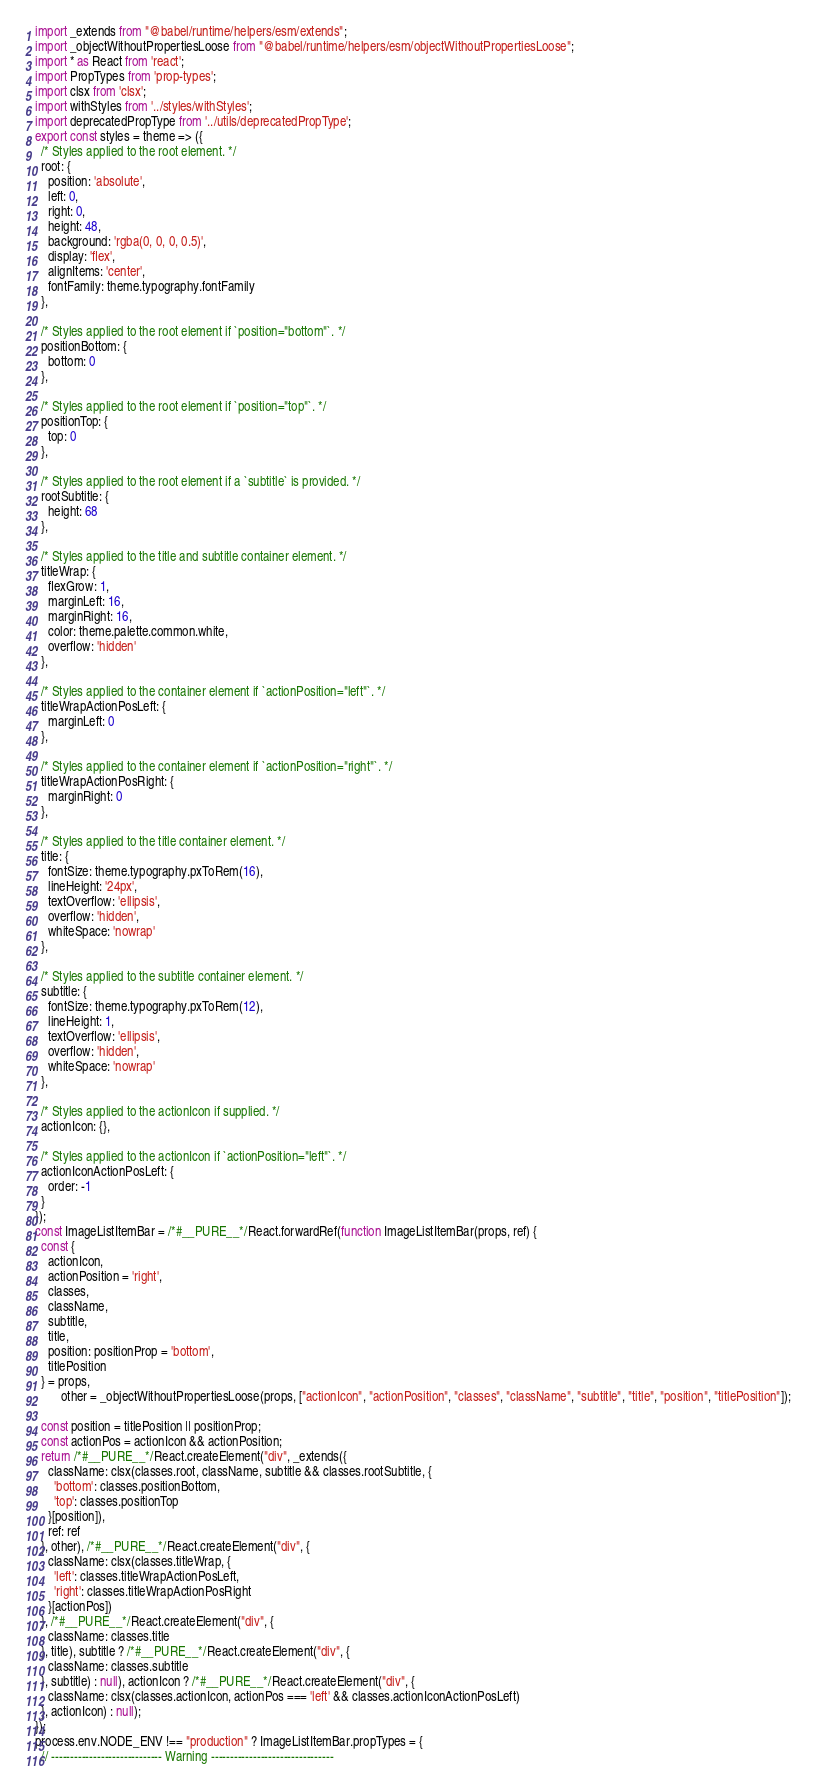Convert code to text. <code><loc_0><loc_0><loc_500><loc_500><_JavaScript_>import _extends from "@babel/runtime/helpers/esm/extends";
import _objectWithoutPropertiesLoose from "@babel/runtime/helpers/esm/objectWithoutPropertiesLoose";
import * as React from 'react';
import PropTypes from 'prop-types';
import clsx from 'clsx';
import withStyles from '../styles/withStyles';
import deprecatedPropType from '../utils/deprecatedPropType';
export const styles = theme => ({
  /* Styles applied to the root element. */
  root: {
    position: 'absolute',
    left: 0,
    right: 0,
    height: 48,
    background: 'rgba(0, 0, 0, 0.5)',
    display: 'flex',
    alignItems: 'center',
    fontFamily: theme.typography.fontFamily
  },

  /* Styles applied to the root element if `position="bottom"`. */
  positionBottom: {
    bottom: 0
  },

  /* Styles applied to the root element if `position="top"`. */
  positionTop: {
    top: 0
  },

  /* Styles applied to the root element if a `subtitle` is provided. */
  rootSubtitle: {
    height: 68
  },

  /* Styles applied to the title and subtitle container element. */
  titleWrap: {
    flexGrow: 1,
    marginLeft: 16,
    marginRight: 16,
    color: theme.palette.common.white,
    overflow: 'hidden'
  },

  /* Styles applied to the container element if `actionPosition="left"`. */
  titleWrapActionPosLeft: {
    marginLeft: 0
  },

  /* Styles applied to the container element if `actionPosition="right"`. */
  titleWrapActionPosRight: {
    marginRight: 0
  },

  /* Styles applied to the title container element. */
  title: {
    fontSize: theme.typography.pxToRem(16),
    lineHeight: '24px',
    textOverflow: 'ellipsis',
    overflow: 'hidden',
    whiteSpace: 'nowrap'
  },

  /* Styles applied to the subtitle container element. */
  subtitle: {
    fontSize: theme.typography.pxToRem(12),
    lineHeight: 1,
    textOverflow: 'ellipsis',
    overflow: 'hidden',
    whiteSpace: 'nowrap'
  },

  /* Styles applied to the actionIcon if supplied. */
  actionIcon: {},

  /* Styles applied to the actionIcon if `actionPosition="left"`. */
  actionIconActionPosLeft: {
    order: -1
  }
});
const ImageListItemBar = /*#__PURE__*/React.forwardRef(function ImageListItemBar(props, ref) {
  const {
    actionIcon,
    actionPosition = 'right',
    classes,
    className,
    subtitle,
    title,
    position: positionProp = 'bottom',
    titlePosition
  } = props,
        other = _objectWithoutPropertiesLoose(props, ["actionIcon", "actionPosition", "classes", "className", "subtitle", "title", "position", "titlePosition"]);

  const position = titlePosition || positionProp;
  const actionPos = actionIcon && actionPosition;
  return /*#__PURE__*/React.createElement("div", _extends({
    className: clsx(classes.root, className, subtitle && classes.rootSubtitle, {
      'bottom': classes.positionBottom,
      'top': classes.positionTop
    }[position]),
    ref: ref
  }, other), /*#__PURE__*/React.createElement("div", {
    className: clsx(classes.titleWrap, {
      'left': classes.titleWrapActionPosLeft,
      'right': classes.titleWrapActionPosRight
    }[actionPos])
  }, /*#__PURE__*/React.createElement("div", {
    className: classes.title
  }, title), subtitle ? /*#__PURE__*/React.createElement("div", {
    className: classes.subtitle
  }, subtitle) : null), actionIcon ? /*#__PURE__*/React.createElement("div", {
    className: clsx(classes.actionIcon, actionPos === 'left' && classes.actionIconActionPosLeft)
  }, actionIcon) : null);
});
process.env.NODE_ENV !== "production" ? ImageListItemBar.propTypes = {
  // ----------------------------- Warning --------------------------------</code> 